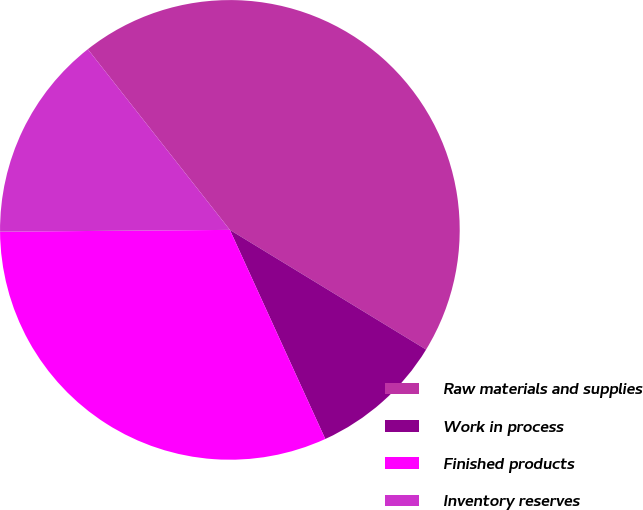<chart> <loc_0><loc_0><loc_500><loc_500><pie_chart><fcel>Raw materials and supplies<fcel>Work in process<fcel>Finished products<fcel>Inventory reserves<nl><fcel>44.32%<fcel>9.47%<fcel>31.69%<fcel>14.52%<nl></chart> 